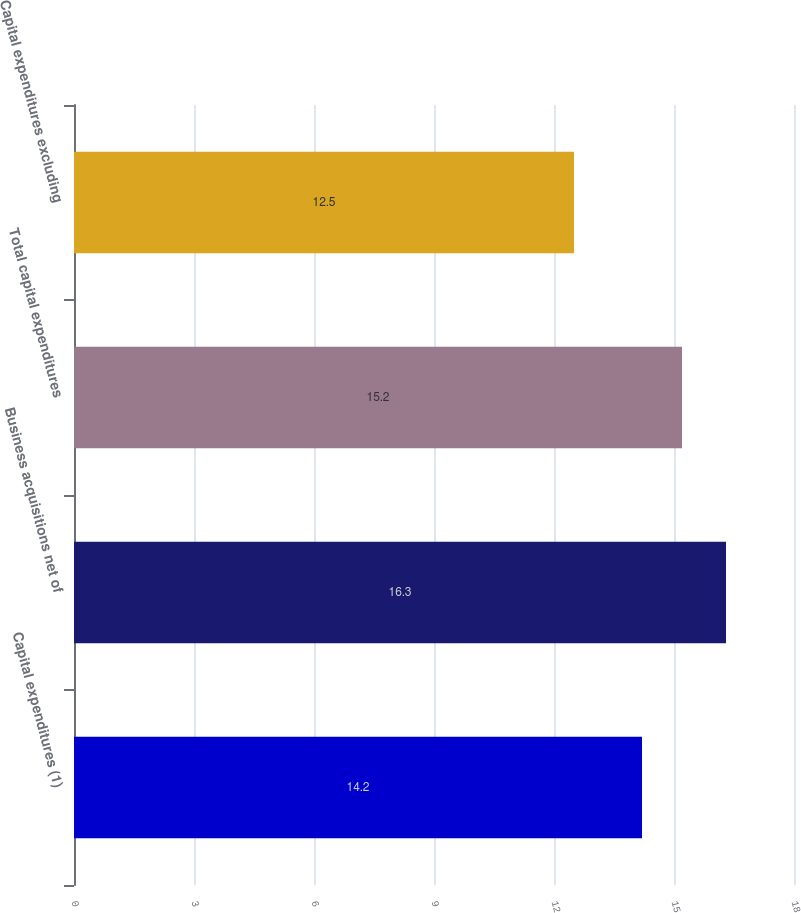<chart> <loc_0><loc_0><loc_500><loc_500><bar_chart><fcel>Capital expenditures (1)<fcel>Business acquisitions net of<fcel>Total capital expenditures<fcel>Capital expenditures excluding<nl><fcel>14.2<fcel>16.3<fcel>15.2<fcel>12.5<nl></chart> 